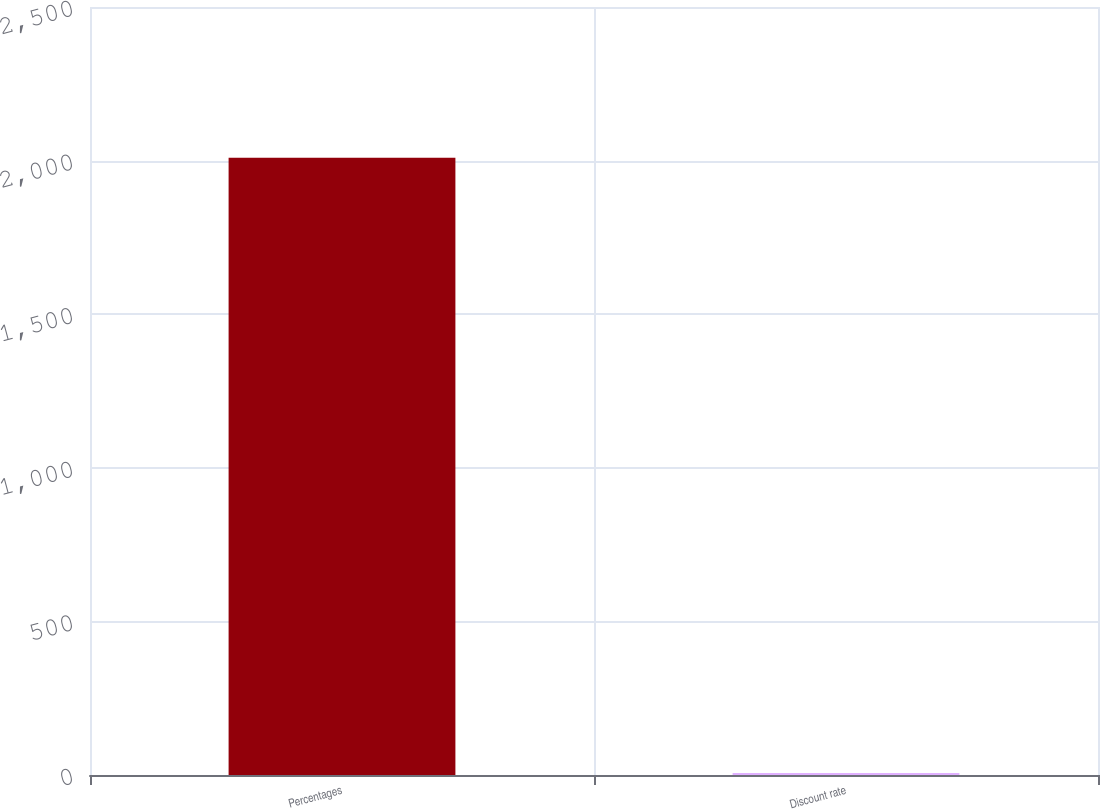<chart> <loc_0><loc_0><loc_500><loc_500><bar_chart><fcel>Percentages<fcel>Discount rate<nl><fcel>2009<fcel>6.25<nl></chart> 